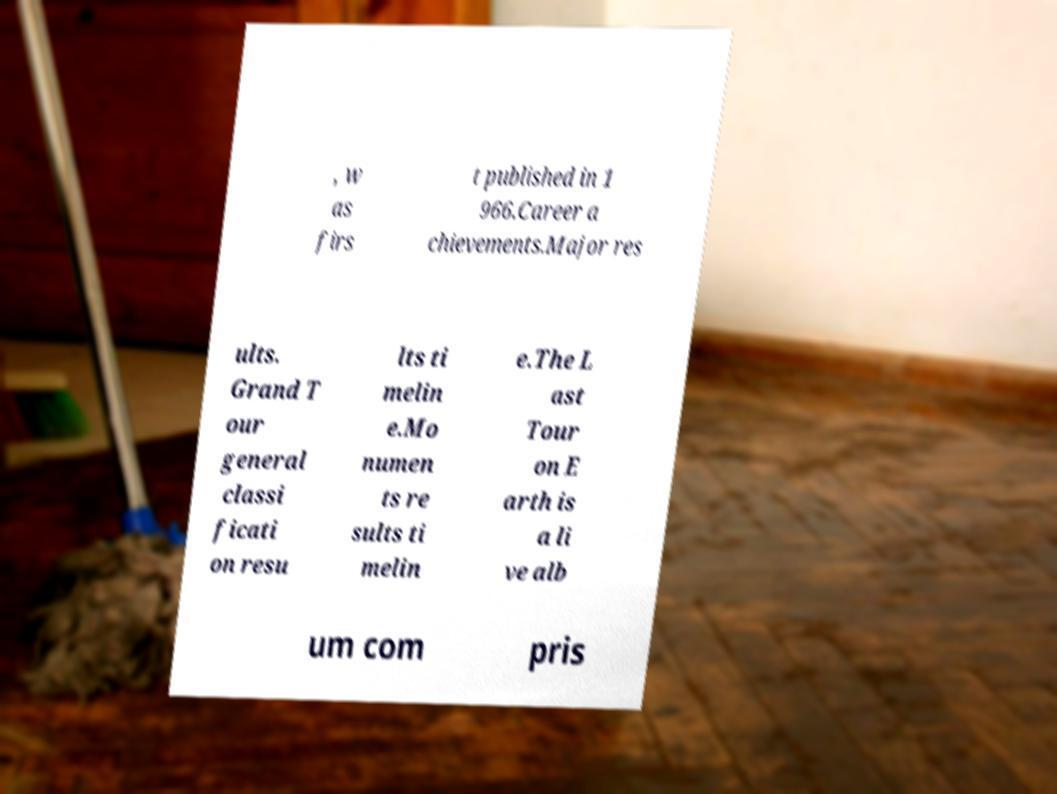Could you extract and type out the text from this image? , w as firs t published in 1 966.Career a chievements.Major res ults. Grand T our general classi ficati on resu lts ti melin e.Mo numen ts re sults ti melin e.The L ast Tour on E arth is a li ve alb um com pris 